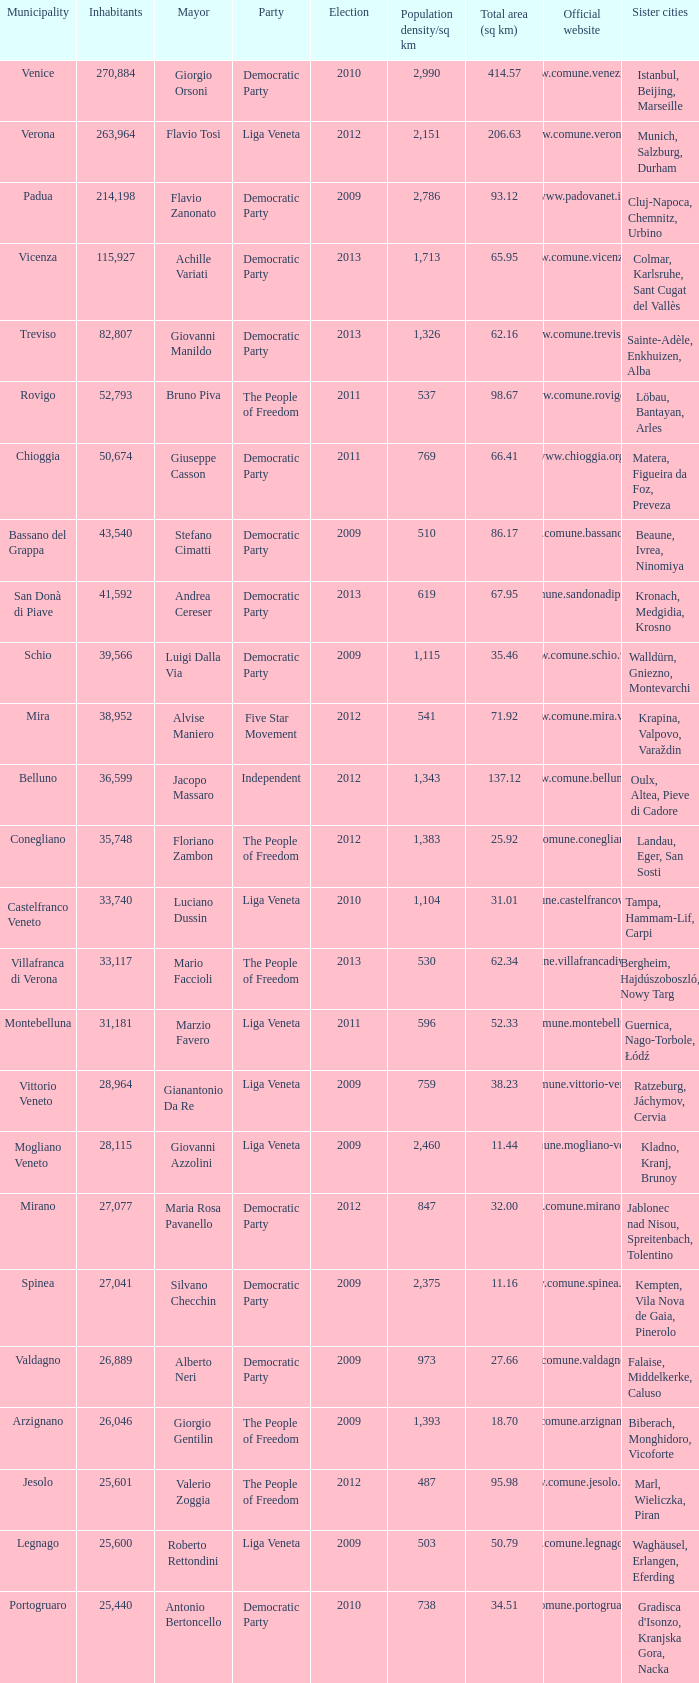Can you parse all the data within this table? {'header': ['Municipality', 'Inhabitants', 'Mayor', 'Party', 'Election', 'Population density/sq km', 'Total area (sq km)', 'Official website', 'Sister cities'], 'rows': [['Venice', '270,884', 'Giorgio Orsoni', 'Democratic Party', '2010', '2,990', '414.57', 'www.comune.venezia.it/', 'Istanbul, Beijing, Marseille'], ['Verona', '263,964', 'Flavio Tosi', 'Liga Veneta', '2012', '2,151', '206.63', 'www.comune.verona.it/', 'Munich, Salzburg, Durham'], ['Padua', '214,198', 'Flavio Zanonato', 'Democratic Party', '2009', '2,786', '93.12', 'www.padovanet.it/', 'Cluj-Napoca, Chemnitz, Urbino'], ['Vicenza', '115,927', 'Achille Variati', 'Democratic Party', '2013', '1,713', '65.95', 'www.comune.vicenza.it/', 'Colmar, Karlsruhe, Sant Cugat del Vallès'], ['Treviso', '82,807', 'Giovanni Manildo', 'Democratic Party', '2013', '1,326', '62.16', 'www.comune.treviso.it/', 'Sainte-Adèle, Enkhuizen, Alba'], ['Rovigo', '52,793', 'Bruno Piva', 'The People of Freedom', '2011', '537', '98.67', 'www.comune.rovigo.it/', 'Löbau, Bantayan, Arles'], ['Chioggia', '50,674', 'Giuseppe Casson', 'Democratic Party', '2011', '769', '66.41', 'www.chioggia.org/', 'Matera, Figueira da Foz, Preveza'], ['Bassano del Grappa', '43,540', 'Stefano Cimatti', 'Democratic Party', '2009', '510', '86.17', 'www.comune.bassano.vi.it/', 'Beaune, Ivrea, Ninomiya'], ['San Donà di Piave', '41,592', 'Andrea Cereser', 'Democratic Party', '2013', '619', '67.95', 'www.comune.sandonadipiave.ve.it/', 'Kronach, Medgidia, Krosno'], ['Schio', '39,566', 'Luigi Dalla Via', 'Democratic Party', '2009', '1,115', '35.46', 'www.comune.schio.vi.it/', 'Walldürn, Gniezno, Montevarchi'], ['Mira', '38,952', 'Alvise Maniero', 'Five Star Movement', '2012', '541', '71.92', 'www.comune.mira.ve.it/', 'Krapina, Valpovo, Varaždin'], ['Belluno', '36,599', 'Jacopo Massaro', 'Independent', '2012', '1,343', '137.12', 'www.comune.belluno.it/', 'Oulx, Altea, Pieve di Cadore'], ['Conegliano', '35,748', 'Floriano Zambon', 'The People of Freedom', '2012', '1,383', '25.92', 'www.comune.conegliano.tv.it/', 'Landau, Eger, San Sosti'], ['Castelfranco Veneto', '33,740', 'Luciano Dussin', 'Liga Veneta', '2010', '1,104', '31.01', 'www.comune.castelfrancoveneto.tv.it/', 'Tampa, Hammam-Lif, Carpi'], ['Villafranca di Verona', '33,117', 'Mario Faccioli', 'The People of Freedom', '2013', '530', '62.34', 'www.comune.villafrancadiverona.vr.it/', 'Bergheim, Hajdúszoboszló, Nowy Targ'], ['Montebelluna', '31,181', 'Marzio Favero', 'Liga Veneta', '2011', '596', '52.33', 'www.comune.montebelluna.tv.it/', 'Guernica, Nago-Torbole, Łódź'], ['Vittorio Veneto', '28,964', 'Gianantonio Da Re', 'Liga Veneta', '2009', '759', '38.23', 'www.comune.vittorio-veneto.tv.it/', 'Ratzeburg, Jáchymov, Cervia'], ['Mogliano Veneto', '28,115', 'Giovanni Azzolini', 'Liga Veneta', '2009', '2,460', '11.44', 'www.comune.mogliano-veneto.tv.it/', 'Kladno, Kranj, Brunoy'], ['Mirano', '27,077', 'Maria Rosa Pavanello', 'Democratic Party', '2012', '847', '32.00', 'www.comune.mirano.ve.it/', 'Jablonec nad Nisou, Spreitenbach, Tolentino'], ['Spinea', '27,041', 'Silvano Checchin', 'Democratic Party', '2009', '2,375', '11.16', 'www.comune.spinea.ve.it/', 'Kempten, Vila Nova de Gaia, Pinerolo'], ['Valdagno', '26,889', 'Alberto Neri', 'Democratic Party', '2009', '973', '27.66', 'www.comune.valdagno.vi.it/', 'Falaise, Middelkerke, Caluso'], ['Arzignano', '26,046', 'Giorgio Gentilin', 'The People of Freedom', '2009', '1,393', '18.70', 'www.comune.arzignano.vi.it/', 'Biberach, Monghidoro, Vicoforte'], ['Jesolo', '25,601', 'Valerio Zoggia', 'The People of Freedom', '2012', '487', '95.98', 'www.comune.jesolo.ve.it/', 'Marl, Wieliczka, Piran'], ['Legnago', '25,600', 'Roberto Rettondini', 'Liga Veneta', '2009', '503', '50.79', 'www.comune.legnago.vr.it/', 'Waghäusel, Erlangen, Eferding'], ['Portogruaro', '25,440', 'Antonio Bertoncello', 'Democratic Party', '2010', '738', '34.51', 'www.comune.portogruaro.ve.it/', "Gradisca d'Isonzo, Kranjska Gora, Nacka"]]} How many Inhabitants were in the democratic party for an election before 2009 for Mayor of stefano cimatti? 0.0. 